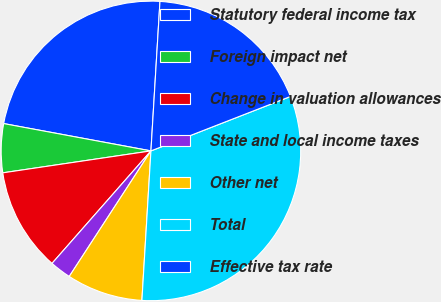Convert chart. <chart><loc_0><loc_0><loc_500><loc_500><pie_chart><fcel>Statutory federal income tax<fcel>Foreign impact net<fcel>Change in valuation allowances<fcel>State and local income taxes<fcel>Other net<fcel>Total<fcel>Effective tax rate<nl><fcel>23.04%<fcel>5.26%<fcel>11.18%<fcel>2.3%<fcel>8.22%<fcel>31.88%<fcel>18.12%<nl></chart> 